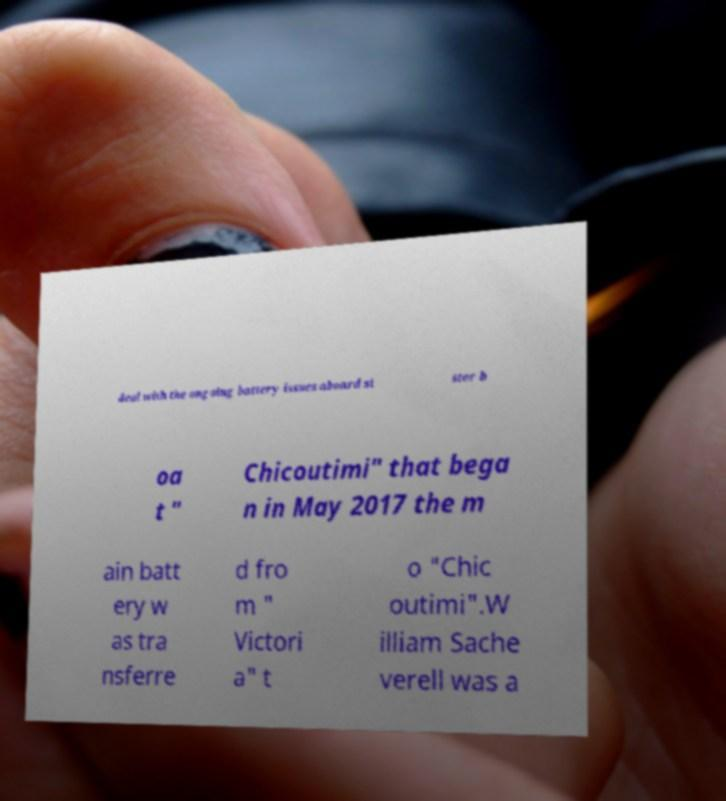What messages or text are displayed in this image? I need them in a readable, typed format. deal with the ongoing battery issues aboard si ster b oa t " Chicoutimi" that bega n in May 2017 the m ain batt ery w as tra nsferre d fro m " Victori a" t o "Chic outimi".W illiam Sache verell was a 